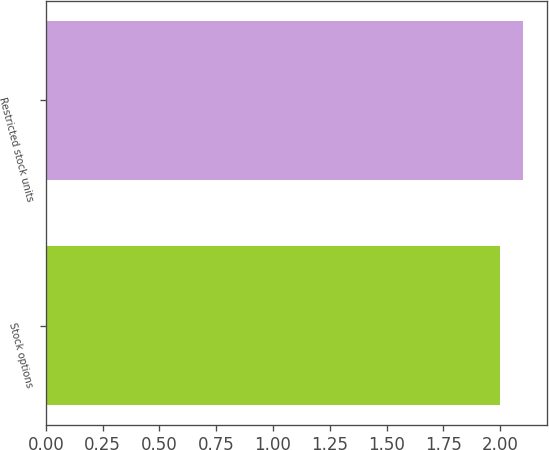Convert chart to OTSL. <chart><loc_0><loc_0><loc_500><loc_500><bar_chart><fcel>Stock options<fcel>Restricted stock units<nl><fcel>2<fcel>2.1<nl></chart> 